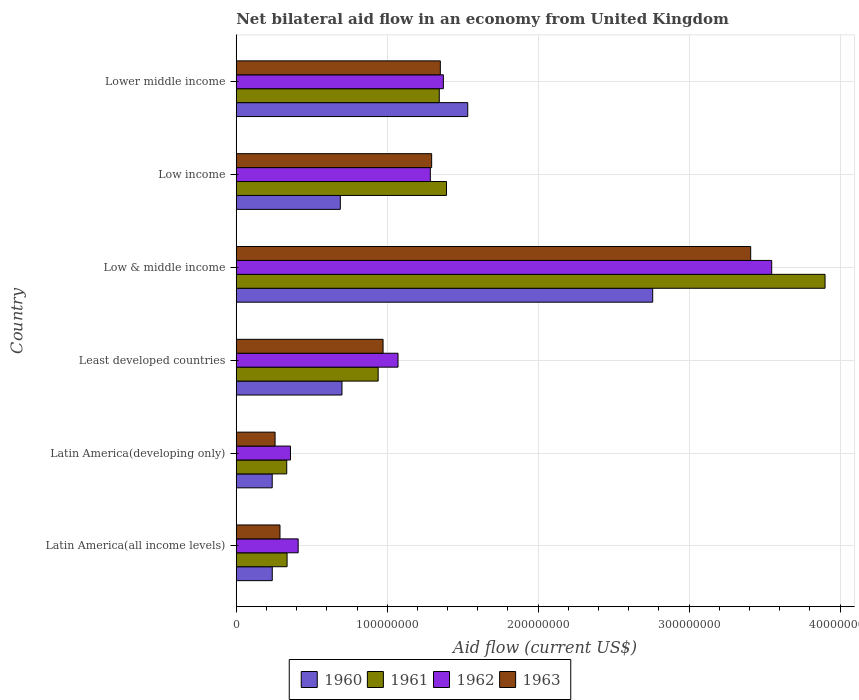How many different coloured bars are there?
Ensure brevity in your answer.  4. How many groups of bars are there?
Offer a terse response. 6. Are the number of bars per tick equal to the number of legend labels?
Offer a very short reply. Yes. What is the label of the 4th group of bars from the top?
Ensure brevity in your answer.  Least developed countries. In how many cases, is the number of bars for a given country not equal to the number of legend labels?
Keep it short and to the point. 0. What is the net bilateral aid flow in 1962 in Latin America(developing only)?
Provide a succinct answer. 3.59e+07. Across all countries, what is the maximum net bilateral aid flow in 1962?
Your answer should be very brief. 3.55e+08. Across all countries, what is the minimum net bilateral aid flow in 1962?
Ensure brevity in your answer.  3.59e+07. In which country was the net bilateral aid flow in 1961 minimum?
Make the answer very short. Latin America(developing only). What is the total net bilateral aid flow in 1962 in the graph?
Offer a very short reply. 8.05e+08. What is the difference between the net bilateral aid flow in 1962 in Low income and that in Lower middle income?
Give a very brief answer. -8.62e+06. What is the difference between the net bilateral aid flow in 1960 in Latin America(developing only) and the net bilateral aid flow in 1962 in Lower middle income?
Offer a very short reply. -1.13e+08. What is the average net bilateral aid flow in 1961 per country?
Keep it short and to the point. 1.38e+08. What is the difference between the net bilateral aid flow in 1961 and net bilateral aid flow in 1962 in Low & middle income?
Keep it short and to the point. 3.54e+07. What is the ratio of the net bilateral aid flow in 1960 in Latin America(all income levels) to that in Least developed countries?
Offer a terse response. 0.34. What is the difference between the highest and the second highest net bilateral aid flow in 1961?
Your answer should be very brief. 2.51e+08. What is the difference between the highest and the lowest net bilateral aid flow in 1960?
Offer a very short reply. 2.52e+08. Is it the case that in every country, the sum of the net bilateral aid flow in 1960 and net bilateral aid flow in 1962 is greater than the sum of net bilateral aid flow in 1963 and net bilateral aid flow in 1961?
Offer a terse response. No. Is it the case that in every country, the sum of the net bilateral aid flow in 1962 and net bilateral aid flow in 1960 is greater than the net bilateral aid flow in 1961?
Keep it short and to the point. Yes. What is the difference between two consecutive major ticks on the X-axis?
Ensure brevity in your answer.  1.00e+08. Are the values on the major ticks of X-axis written in scientific E-notation?
Your answer should be compact. No. Does the graph contain any zero values?
Make the answer very short. No. Where does the legend appear in the graph?
Your response must be concise. Bottom center. What is the title of the graph?
Your answer should be compact. Net bilateral aid flow in an economy from United Kingdom. Does "2001" appear as one of the legend labels in the graph?
Your answer should be very brief. No. What is the label or title of the Y-axis?
Provide a succinct answer. Country. What is the Aid flow (current US$) of 1960 in Latin America(all income levels)?
Give a very brief answer. 2.39e+07. What is the Aid flow (current US$) in 1961 in Latin America(all income levels)?
Offer a very short reply. 3.37e+07. What is the Aid flow (current US$) in 1962 in Latin America(all income levels)?
Keep it short and to the point. 4.10e+07. What is the Aid flow (current US$) in 1963 in Latin America(all income levels)?
Your answer should be compact. 2.90e+07. What is the Aid flow (current US$) of 1960 in Latin America(developing only)?
Your answer should be compact. 2.38e+07. What is the Aid flow (current US$) of 1961 in Latin America(developing only)?
Your answer should be compact. 3.34e+07. What is the Aid flow (current US$) of 1962 in Latin America(developing only)?
Your response must be concise. 3.59e+07. What is the Aid flow (current US$) in 1963 in Latin America(developing only)?
Ensure brevity in your answer.  2.57e+07. What is the Aid flow (current US$) in 1960 in Least developed countries?
Your answer should be compact. 7.00e+07. What is the Aid flow (current US$) in 1961 in Least developed countries?
Provide a succinct answer. 9.40e+07. What is the Aid flow (current US$) of 1962 in Least developed countries?
Your answer should be compact. 1.07e+08. What is the Aid flow (current US$) in 1963 in Least developed countries?
Provide a succinct answer. 9.73e+07. What is the Aid flow (current US$) in 1960 in Low & middle income?
Provide a succinct answer. 2.76e+08. What is the Aid flow (current US$) in 1961 in Low & middle income?
Your answer should be very brief. 3.90e+08. What is the Aid flow (current US$) in 1962 in Low & middle income?
Ensure brevity in your answer.  3.55e+08. What is the Aid flow (current US$) in 1963 in Low & middle income?
Ensure brevity in your answer.  3.41e+08. What is the Aid flow (current US$) of 1960 in Low income?
Provide a succinct answer. 6.90e+07. What is the Aid flow (current US$) of 1961 in Low income?
Keep it short and to the point. 1.39e+08. What is the Aid flow (current US$) of 1962 in Low income?
Your answer should be very brief. 1.29e+08. What is the Aid flow (current US$) in 1963 in Low income?
Ensure brevity in your answer.  1.29e+08. What is the Aid flow (current US$) of 1960 in Lower middle income?
Your answer should be very brief. 1.53e+08. What is the Aid flow (current US$) in 1961 in Lower middle income?
Make the answer very short. 1.34e+08. What is the Aid flow (current US$) of 1962 in Lower middle income?
Ensure brevity in your answer.  1.37e+08. What is the Aid flow (current US$) of 1963 in Lower middle income?
Your response must be concise. 1.35e+08. Across all countries, what is the maximum Aid flow (current US$) in 1960?
Provide a succinct answer. 2.76e+08. Across all countries, what is the maximum Aid flow (current US$) in 1961?
Your answer should be compact. 3.90e+08. Across all countries, what is the maximum Aid flow (current US$) in 1962?
Make the answer very short. 3.55e+08. Across all countries, what is the maximum Aid flow (current US$) in 1963?
Keep it short and to the point. 3.41e+08. Across all countries, what is the minimum Aid flow (current US$) of 1960?
Ensure brevity in your answer.  2.38e+07. Across all countries, what is the minimum Aid flow (current US$) of 1961?
Ensure brevity in your answer.  3.34e+07. Across all countries, what is the minimum Aid flow (current US$) in 1962?
Offer a very short reply. 3.59e+07. Across all countries, what is the minimum Aid flow (current US$) of 1963?
Provide a succinct answer. 2.57e+07. What is the total Aid flow (current US$) of 1960 in the graph?
Provide a succinct answer. 6.16e+08. What is the total Aid flow (current US$) of 1961 in the graph?
Provide a short and direct response. 8.25e+08. What is the total Aid flow (current US$) in 1962 in the graph?
Offer a terse response. 8.05e+08. What is the total Aid flow (current US$) of 1963 in the graph?
Keep it short and to the point. 7.57e+08. What is the difference between the Aid flow (current US$) in 1961 in Latin America(all income levels) and that in Latin America(developing only)?
Your response must be concise. 2.20e+05. What is the difference between the Aid flow (current US$) of 1962 in Latin America(all income levels) and that in Latin America(developing only)?
Offer a very short reply. 5.10e+06. What is the difference between the Aid flow (current US$) of 1963 in Latin America(all income levels) and that in Latin America(developing only)?
Your response must be concise. 3.25e+06. What is the difference between the Aid flow (current US$) of 1960 in Latin America(all income levels) and that in Least developed countries?
Your answer should be very brief. -4.62e+07. What is the difference between the Aid flow (current US$) in 1961 in Latin America(all income levels) and that in Least developed countries?
Provide a short and direct response. -6.04e+07. What is the difference between the Aid flow (current US$) of 1962 in Latin America(all income levels) and that in Least developed countries?
Your response must be concise. -6.62e+07. What is the difference between the Aid flow (current US$) in 1963 in Latin America(all income levels) and that in Least developed countries?
Your answer should be compact. -6.83e+07. What is the difference between the Aid flow (current US$) of 1960 in Latin America(all income levels) and that in Low & middle income?
Give a very brief answer. -2.52e+08. What is the difference between the Aid flow (current US$) in 1961 in Latin America(all income levels) and that in Low & middle income?
Your answer should be very brief. -3.56e+08. What is the difference between the Aid flow (current US$) of 1962 in Latin America(all income levels) and that in Low & middle income?
Keep it short and to the point. -3.14e+08. What is the difference between the Aid flow (current US$) of 1963 in Latin America(all income levels) and that in Low & middle income?
Offer a terse response. -3.12e+08. What is the difference between the Aid flow (current US$) of 1960 in Latin America(all income levels) and that in Low income?
Offer a very short reply. -4.51e+07. What is the difference between the Aid flow (current US$) of 1961 in Latin America(all income levels) and that in Low income?
Your response must be concise. -1.06e+08. What is the difference between the Aid flow (current US$) of 1962 in Latin America(all income levels) and that in Low income?
Provide a succinct answer. -8.76e+07. What is the difference between the Aid flow (current US$) in 1963 in Latin America(all income levels) and that in Low income?
Ensure brevity in your answer.  -1.00e+08. What is the difference between the Aid flow (current US$) in 1960 in Latin America(all income levels) and that in Lower middle income?
Ensure brevity in your answer.  -1.30e+08. What is the difference between the Aid flow (current US$) of 1961 in Latin America(all income levels) and that in Lower middle income?
Ensure brevity in your answer.  -1.01e+08. What is the difference between the Aid flow (current US$) of 1962 in Latin America(all income levels) and that in Lower middle income?
Your response must be concise. -9.62e+07. What is the difference between the Aid flow (current US$) of 1963 in Latin America(all income levels) and that in Lower middle income?
Your answer should be very brief. -1.06e+08. What is the difference between the Aid flow (current US$) in 1960 in Latin America(developing only) and that in Least developed countries?
Ensure brevity in your answer.  -4.62e+07. What is the difference between the Aid flow (current US$) in 1961 in Latin America(developing only) and that in Least developed countries?
Offer a terse response. -6.06e+07. What is the difference between the Aid flow (current US$) in 1962 in Latin America(developing only) and that in Least developed countries?
Ensure brevity in your answer.  -7.13e+07. What is the difference between the Aid flow (current US$) in 1963 in Latin America(developing only) and that in Least developed countries?
Ensure brevity in your answer.  -7.16e+07. What is the difference between the Aid flow (current US$) of 1960 in Latin America(developing only) and that in Low & middle income?
Ensure brevity in your answer.  -2.52e+08. What is the difference between the Aid flow (current US$) of 1961 in Latin America(developing only) and that in Low & middle income?
Make the answer very short. -3.57e+08. What is the difference between the Aid flow (current US$) of 1962 in Latin America(developing only) and that in Low & middle income?
Give a very brief answer. -3.19e+08. What is the difference between the Aid flow (current US$) in 1963 in Latin America(developing only) and that in Low & middle income?
Make the answer very short. -3.15e+08. What is the difference between the Aid flow (current US$) in 1960 in Latin America(developing only) and that in Low income?
Keep it short and to the point. -4.51e+07. What is the difference between the Aid flow (current US$) in 1961 in Latin America(developing only) and that in Low income?
Offer a terse response. -1.06e+08. What is the difference between the Aid flow (current US$) in 1962 in Latin America(developing only) and that in Low income?
Your answer should be compact. -9.27e+07. What is the difference between the Aid flow (current US$) of 1963 in Latin America(developing only) and that in Low income?
Offer a terse response. -1.04e+08. What is the difference between the Aid flow (current US$) in 1960 in Latin America(developing only) and that in Lower middle income?
Offer a very short reply. -1.30e+08. What is the difference between the Aid flow (current US$) in 1961 in Latin America(developing only) and that in Lower middle income?
Your answer should be very brief. -1.01e+08. What is the difference between the Aid flow (current US$) in 1962 in Latin America(developing only) and that in Lower middle income?
Offer a very short reply. -1.01e+08. What is the difference between the Aid flow (current US$) of 1963 in Latin America(developing only) and that in Lower middle income?
Offer a terse response. -1.09e+08. What is the difference between the Aid flow (current US$) of 1960 in Least developed countries and that in Low & middle income?
Offer a very short reply. -2.06e+08. What is the difference between the Aid flow (current US$) in 1961 in Least developed countries and that in Low & middle income?
Offer a terse response. -2.96e+08. What is the difference between the Aid flow (current US$) in 1962 in Least developed countries and that in Low & middle income?
Offer a very short reply. -2.48e+08. What is the difference between the Aid flow (current US$) of 1963 in Least developed countries and that in Low & middle income?
Your answer should be very brief. -2.44e+08. What is the difference between the Aid flow (current US$) of 1960 in Least developed countries and that in Low income?
Your answer should be very brief. 1.09e+06. What is the difference between the Aid flow (current US$) in 1961 in Least developed countries and that in Low income?
Give a very brief answer. -4.53e+07. What is the difference between the Aid flow (current US$) in 1962 in Least developed countries and that in Low income?
Ensure brevity in your answer.  -2.14e+07. What is the difference between the Aid flow (current US$) of 1963 in Least developed countries and that in Low income?
Keep it short and to the point. -3.22e+07. What is the difference between the Aid flow (current US$) of 1960 in Least developed countries and that in Lower middle income?
Give a very brief answer. -8.33e+07. What is the difference between the Aid flow (current US$) of 1961 in Least developed countries and that in Lower middle income?
Make the answer very short. -4.05e+07. What is the difference between the Aid flow (current US$) of 1962 in Least developed countries and that in Lower middle income?
Offer a very short reply. -3.00e+07. What is the difference between the Aid flow (current US$) of 1963 in Least developed countries and that in Lower middle income?
Your response must be concise. -3.79e+07. What is the difference between the Aid flow (current US$) in 1960 in Low & middle income and that in Low income?
Provide a short and direct response. 2.07e+08. What is the difference between the Aid flow (current US$) of 1961 in Low & middle income and that in Low income?
Make the answer very short. 2.51e+08. What is the difference between the Aid flow (current US$) in 1962 in Low & middle income and that in Low income?
Offer a terse response. 2.26e+08. What is the difference between the Aid flow (current US$) in 1963 in Low & middle income and that in Low income?
Ensure brevity in your answer.  2.11e+08. What is the difference between the Aid flow (current US$) in 1960 in Low & middle income and that in Lower middle income?
Give a very brief answer. 1.23e+08. What is the difference between the Aid flow (current US$) in 1961 in Low & middle income and that in Lower middle income?
Offer a terse response. 2.56e+08. What is the difference between the Aid flow (current US$) of 1962 in Low & middle income and that in Lower middle income?
Your response must be concise. 2.18e+08. What is the difference between the Aid flow (current US$) in 1963 in Low & middle income and that in Lower middle income?
Your answer should be compact. 2.06e+08. What is the difference between the Aid flow (current US$) in 1960 in Low income and that in Lower middle income?
Make the answer very short. -8.44e+07. What is the difference between the Aid flow (current US$) in 1961 in Low income and that in Lower middle income?
Ensure brevity in your answer.  4.79e+06. What is the difference between the Aid flow (current US$) in 1962 in Low income and that in Lower middle income?
Ensure brevity in your answer.  -8.62e+06. What is the difference between the Aid flow (current US$) in 1963 in Low income and that in Lower middle income?
Your answer should be very brief. -5.75e+06. What is the difference between the Aid flow (current US$) in 1960 in Latin America(all income levels) and the Aid flow (current US$) in 1961 in Latin America(developing only)?
Ensure brevity in your answer.  -9.59e+06. What is the difference between the Aid flow (current US$) of 1960 in Latin America(all income levels) and the Aid flow (current US$) of 1962 in Latin America(developing only)?
Provide a short and direct response. -1.21e+07. What is the difference between the Aid flow (current US$) of 1960 in Latin America(all income levels) and the Aid flow (current US$) of 1963 in Latin America(developing only)?
Provide a succinct answer. -1.86e+06. What is the difference between the Aid flow (current US$) of 1961 in Latin America(all income levels) and the Aid flow (current US$) of 1962 in Latin America(developing only)?
Offer a very short reply. -2.25e+06. What is the difference between the Aid flow (current US$) in 1961 in Latin America(all income levels) and the Aid flow (current US$) in 1963 in Latin America(developing only)?
Your answer should be compact. 7.95e+06. What is the difference between the Aid flow (current US$) of 1962 in Latin America(all income levels) and the Aid flow (current US$) of 1963 in Latin America(developing only)?
Your answer should be compact. 1.53e+07. What is the difference between the Aid flow (current US$) in 1960 in Latin America(all income levels) and the Aid flow (current US$) in 1961 in Least developed countries?
Keep it short and to the point. -7.02e+07. What is the difference between the Aid flow (current US$) in 1960 in Latin America(all income levels) and the Aid flow (current US$) in 1962 in Least developed countries?
Your answer should be compact. -8.33e+07. What is the difference between the Aid flow (current US$) of 1960 in Latin America(all income levels) and the Aid flow (current US$) of 1963 in Least developed countries?
Ensure brevity in your answer.  -7.34e+07. What is the difference between the Aid flow (current US$) in 1961 in Latin America(all income levels) and the Aid flow (current US$) in 1962 in Least developed countries?
Your response must be concise. -7.35e+07. What is the difference between the Aid flow (current US$) in 1961 in Latin America(all income levels) and the Aid flow (current US$) in 1963 in Least developed countries?
Provide a succinct answer. -6.36e+07. What is the difference between the Aid flow (current US$) in 1962 in Latin America(all income levels) and the Aid flow (current US$) in 1963 in Least developed countries?
Your answer should be very brief. -5.62e+07. What is the difference between the Aid flow (current US$) of 1960 in Latin America(all income levels) and the Aid flow (current US$) of 1961 in Low & middle income?
Your response must be concise. -3.66e+08. What is the difference between the Aid flow (current US$) of 1960 in Latin America(all income levels) and the Aid flow (current US$) of 1962 in Low & middle income?
Your answer should be very brief. -3.31e+08. What is the difference between the Aid flow (current US$) of 1960 in Latin America(all income levels) and the Aid flow (current US$) of 1963 in Low & middle income?
Offer a very short reply. -3.17e+08. What is the difference between the Aid flow (current US$) of 1961 in Latin America(all income levels) and the Aid flow (current US$) of 1962 in Low & middle income?
Offer a very short reply. -3.21e+08. What is the difference between the Aid flow (current US$) of 1961 in Latin America(all income levels) and the Aid flow (current US$) of 1963 in Low & middle income?
Make the answer very short. -3.07e+08. What is the difference between the Aid flow (current US$) in 1962 in Latin America(all income levels) and the Aid flow (current US$) in 1963 in Low & middle income?
Provide a succinct answer. -3.00e+08. What is the difference between the Aid flow (current US$) in 1960 in Latin America(all income levels) and the Aid flow (current US$) in 1961 in Low income?
Your response must be concise. -1.15e+08. What is the difference between the Aid flow (current US$) of 1960 in Latin America(all income levels) and the Aid flow (current US$) of 1962 in Low income?
Offer a very short reply. -1.05e+08. What is the difference between the Aid flow (current US$) in 1960 in Latin America(all income levels) and the Aid flow (current US$) in 1963 in Low income?
Make the answer very short. -1.06e+08. What is the difference between the Aid flow (current US$) of 1961 in Latin America(all income levels) and the Aid flow (current US$) of 1962 in Low income?
Give a very brief answer. -9.49e+07. What is the difference between the Aid flow (current US$) of 1961 in Latin America(all income levels) and the Aid flow (current US$) of 1963 in Low income?
Make the answer very short. -9.58e+07. What is the difference between the Aid flow (current US$) in 1962 in Latin America(all income levels) and the Aid flow (current US$) in 1963 in Low income?
Provide a succinct answer. -8.84e+07. What is the difference between the Aid flow (current US$) of 1960 in Latin America(all income levels) and the Aid flow (current US$) of 1961 in Lower middle income?
Your answer should be compact. -1.11e+08. What is the difference between the Aid flow (current US$) in 1960 in Latin America(all income levels) and the Aid flow (current US$) in 1962 in Lower middle income?
Provide a short and direct response. -1.13e+08. What is the difference between the Aid flow (current US$) in 1960 in Latin America(all income levels) and the Aid flow (current US$) in 1963 in Lower middle income?
Provide a short and direct response. -1.11e+08. What is the difference between the Aid flow (current US$) of 1961 in Latin America(all income levels) and the Aid flow (current US$) of 1962 in Lower middle income?
Offer a very short reply. -1.04e+08. What is the difference between the Aid flow (current US$) in 1961 in Latin America(all income levels) and the Aid flow (current US$) in 1963 in Lower middle income?
Your answer should be compact. -1.02e+08. What is the difference between the Aid flow (current US$) of 1962 in Latin America(all income levels) and the Aid flow (current US$) of 1963 in Lower middle income?
Your answer should be very brief. -9.42e+07. What is the difference between the Aid flow (current US$) of 1960 in Latin America(developing only) and the Aid flow (current US$) of 1961 in Least developed countries?
Your answer should be very brief. -7.02e+07. What is the difference between the Aid flow (current US$) of 1960 in Latin America(developing only) and the Aid flow (current US$) of 1962 in Least developed countries?
Your answer should be compact. -8.34e+07. What is the difference between the Aid flow (current US$) in 1960 in Latin America(developing only) and the Aid flow (current US$) in 1963 in Least developed countries?
Ensure brevity in your answer.  -7.34e+07. What is the difference between the Aid flow (current US$) of 1961 in Latin America(developing only) and the Aid flow (current US$) of 1962 in Least developed countries?
Provide a succinct answer. -7.37e+07. What is the difference between the Aid flow (current US$) in 1961 in Latin America(developing only) and the Aid flow (current US$) in 1963 in Least developed countries?
Provide a short and direct response. -6.38e+07. What is the difference between the Aid flow (current US$) of 1962 in Latin America(developing only) and the Aid flow (current US$) of 1963 in Least developed countries?
Make the answer very short. -6.14e+07. What is the difference between the Aid flow (current US$) in 1960 in Latin America(developing only) and the Aid flow (current US$) in 1961 in Low & middle income?
Ensure brevity in your answer.  -3.66e+08. What is the difference between the Aid flow (current US$) in 1960 in Latin America(developing only) and the Aid flow (current US$) in 1962 in Low & middle income?
Ensure brevity in your answer.  -3.31e+08. What is the difference between the Aid flow (current US$) in 1960 in Latin America(developing only) and the Aid flow (current US$) in 1963 in Low & middle income?
Ensure brevity in your answer.  -3.17e+08. What is the difference between the Aid flow (current US$) of 1961 in Latin America(developing only) and the Aid flow (current US$) of 1962 in Low & middle income?
Offer a very short reply. -3.21e+08. What is the difference between the Aid flow (current US$) in 1961 in Latin America(developing only) and the Aid flow (current US$) in 1963 in Low & middle income?
Offer a terse response. -3.07e+08. What is the difference between the Aid flow (current US$) in 1962 in Latin America(developing only) and the Aid flow (current US$) in 1963 in Low & middle income?
Give a very brief answer. -3.05e+08. What is the difference between the Aid flow (current US$) in 1960 in Latin America(developing only) and the Aid flow (current US$) in 1961 in Low income?
Provide a succinct answer. -1.15e+08. What is the difference between the Aid flow (current US$) of 1960 in Latin America(developing only) and the Aid flow (current US$) of 1962 in Low income?
Your answer should be very brief. -1.05e+08. What is the difference between the Aid flow (current US$) in 1960 in Latin America(developing only) and the Aid flow (current US$) in 1963 in Low income?
Your response must be concise. -1.06e+08. What is the difference between the Aid flow (current US$) in 1961 in Latin America(developing only) and the Aid flow (current US$) in 1962 in Low income?
Give a very brief answer. -9.51e+07. What is the difference between the Aid flow (current US$) of 1961 in Latin America(developing only) and the Aid flow (current US$) of 1963 in Low income?
Give a very brief answer. -9.60e+07. What is the difference between the Aid flow (current US$) in 1962 in Latin America(developing only) and the Aid flow (current US$) in 1963 in Low income?
Make the answer very short. -9.35e+07. What is the difference between the Aid flow (current US$) in 1960 in Latin America(developing only) and the Aid flow (current US$) in 1961 in Lower middle income?
Ensure brevity in your answer.  -1.11e+08. What is the difference between the Aid flow (current US$) in 1960 in Latin America(developing only) and the Aid flow (current US$) in 1962 in Lower middle income?
Provide a short and direct response. -1.13e+08. What is the difference between the Aid flow (current US$) of 1960 in Latin America(developing only) and the Aid flow (current US$) of 1963 in Lower middle income?
Keep it short and to the point. -1.11e+08. What is the difference between the Aid flow (current US$) in 1961 in Latin America(developing only) and the Aid flow (current US$) in 1962 in Lower middle income?
Offer a terse response. -1.04e+08. What is the difference between the Aid flow (current US$) in 1961 in Latin America(developing only) and the Aid flow (current US$) in 1963 in Lower middle income?
Make the answer very short. -1.02e+08. What is the difference between the Aid flow (current US$) of 1962 in Latin America(developing only) and the Aid flow (current US$) of 1963 in Lower middle income?
Provide a succinct answer. -9.93e+07. What is the difference between the Aid flow (current US$) in 1960 in Least developed countries and the Aid flow (current US$) in 1961 in Low & middle income?
Provide a short and direct response. -3.20e+08. What is the difference between the Aid flow (current US$) in 1960 in Least developed countries and the Aid flow (current US$) in 1962 in Low & middle income?
Provide a succinct answer. -2.85e+08. What is the difference between the Aid flow (current US$) in 1960 in Least developed countries and the Aid flow (current US$) in 1963 in Low & middle income?
Offer a terse response. -2.71e+08. What is the difference between the Aid flow (current US$) of 1961 in Least developed countries and the Aid flow (current US$) of 1962 in Low & middle income?
Your answer should be very brief. -2.61e+08. What is the difference between the Aid flow (current US$) of 1961 in Least developed countries and the Aid flow (current US$) of 1963 in Low & middle income?
Offer a terse response. -2.47e+08. What is the difference between the Aid flow (current US$) of 1962 in Least developed countries and the Aid flow (current US$) of 1963 in Low & middle income?
Ensure brevity in your answer.  -2.34e+08. What is the difference between the Aid flow (current US$) in 1960 in Least developed countries and the Aid flow (current US$) in 1961 in Low income?
Offer a terse response. -6.92e+07. What is the difference between the Aid flow (current US$) in 1960 in Least developed countries and the Aid flow (current US$) in 1962 in Low income?
Offer a terse response. -5.85e+07. What is the difference between the Aid flow (current US$) of 1960 in Least developed countries and the Aid flow (current US$) of 1963 in Low income?
Your answer should be compact. -5.94e+07. What is the difference between the Aid flow (current US$) of 1961 in Least developed countries and the Aid flow (current US$) of 1962 in Low income?
Offer a terse response. -3.46e+07. What is the difference between the Aid flow (current US$) of 1961 in Least developed countries and the Aid flow (current US$) of 1963 in Low income?
Offer a terse response. -3.54e+07. What is the difference between the Aid flow (current US$) of 1962 in Least developed countries and the Aid flow (current US$) of 1963 in Low income?
Provide a short and direct response. -2.23e+07. What is the difference between the Aid flow (current US$) of 1960 in Least developed countries and the Aid flow (current US$) of 1961 in Lower middle income?
Offer a very short reply. -6.45e+07. What is the difference between the Aid flow (current US$) in 1960 in Least developed countries and the Aid flow (current US$) in 1962 in Lower middle income?
Ensure brevity in your answer.  -6.72e+07. What is the difference between the Aid flow (current US$) of 1960 in Least developed countries and the Aid flow (current US$) of 1963 in Lower middle income?
Your response must be concise. -6.52e+07. What is the difference between the Aid flow (current US$) in 1961 in Least developed countries and the Aid flow (current US$) in 1962 in Lower middle income?
Give a very brief answer. -4.32e+07. What is the difference between the Aid flow (current US$) of 1961 in Least developed countries and the Aid flow (current US$) of 1963 in Lower middle income?
Keep it short and to the point. -4.12e+07. What is the difference between the Aid flow (current US$) in 1962 in Least developed countries and the Aid flow (current US$) in 1963 in Lower middle income?
Your response must be concise. -2.80e+07. What is the difference between the Aid flow (current US$) of 1960 in Low & middle income and the Aid flow (current US$) of 1961 in Low income?
Provide a succinct answer. 1.37e+08. What is the difference between the Aid flow (current US$) in 1960 in Low & middle income and the Aid flow (current US$) in 1962 in Low income?
Your answer should be compact. 1.47e+08. What is the difference between the Aid flow (current US$) in 1960 in Low & middle income and the Aid flow (current US$) in 1963 in Low income?
Your response must be concise. 1.46e+08. What is the difference between the Aid flow (current US$) in 1961 in Low & middle income and the Aid flow (current US$) in 1962 in Low income?
Your response must be concise. 2.62e+08. What is the difference between the Aid flow (current US$) of 1961 in Low & middle income and the Aid flow (current US$) of 1963 in Low income?
Make the answer very short. 2.61e+08. What is the difference between the Aid flow (current US$) of 1962 in Low & middle income and the Aid flow (current US$) of 1963 in Low income?
Provide a short and direct response. 2.25e+08. What is the difference between the Aid flow (current US$) of 1960 in Low & middle income and the Aid flow (current US$) of 1961 in Lower middle income?
Keep it short and to the point. 1.41e+08. What is the difference between the Aid flow (current US$) in 1960 in Low & middle income and the Aid flow (current US$) in 1962 in Lower middle income?
Provide a succinct answer. 1.39e+08. What is the difference between the Aid flow (current US$) of 1960 in Low & middle income and the Aid flow (current US$) of 1963 in Lower middle income?
Keep it short and to the point. 1.41e+08. What is the difference between the Aid flow (current US$) in 1961 in Low & middle income and the Aid flow (current US$) in 1962 in Lower middle income?
Your answer should be compact. 2.53e+08. What is the difference between the Aid flow (current US$) of 1961 in Low & middle income and the Aid flow (current US$) of 1963 in Lower middle income?
Offer a terse response. 2.55e+08. What is the difference between the Aid flow (current US$) in 1962 in Low & middle income and the Aid flow (current US$) in 1963 in Lower middle income?
Give a very brief answer. 2.20e+08. What is the difference between the Aid flow (current US$) in 1960 in Low income and the Aid flow (current US$) in 1961 in Lower middle income?
Ensure brevity in your answer.  -6.56e+07. What is the difference between the Aid flow (current US$) in 1960 in Low income and the Aid flow (current US$) in 1962 in Lower middle income?
Your response must be concise. -6.82e+07. What is the difference between the Aid flow (current US$) of 1960 in Low income and the Aid flow (current US$) of 1963 in Lower middle income?
Your answer should be very brief. -6.63e+07. What is the difference between the Aid flow (current US$) in 1961 in Low income and the Aid flow (current US$) in 1962 in Lower middle income?
Keep it short and to the point. 2.09e+06. What is the difference between the Aid flow (current US$) in 1961 in Low income and the Aid flow (current US$) in 1963 in Lower middle income?
Offer a terse response. 4.08e+06. What is the difference between the Aid flow (current US$) of 1962 in Low income and the Aid flow (current US$) of 1963 in Lower middle income?
Provide a short and direct response. -6.63e+06. What is the average Aid flow (current US$) of 1960 per country?
Give a very brief answer. 1.03e+08. What is the average Aid flow (current US$) in 1961 per country?
Ensure brevity in your answer.  1.38e+08. What is the average Aid flow (current US$) of 1962 per country?
Your response must be concise. 1.34e+08. What is the average Aid flow (current US$) in 1963 per country?
Provide a short and direct response. 1.26e+08. What is the difference between the Aid flow (current US$) of 1960 and Aid flow (current US$) of 1961 in Latin America(all income levels)?
Keep it short and to the point. -9.81e+06. What is the difference between the Aid flow (current US$) in 1960 and Aid flow (current US$) in 1962 in Latin America(all income levels)?
Provide a succinct answer. -1.72e+07. What is the difference between the Aid flow (current US$) of 1960 and Aid flow (current US$) of 1963 in Latin America(all income levels)?
Offer a very short reply. -5.11e+06. What is the difference between the Aid flow (current US$) in 1961 and Aid flow (current US$) in 1962 in Latin America(all income levels)?
Offer a very short reply. -7.35e+06. What is the difference between the Aid flow (current US$) in 1961 and Aid flow (current US$) in 1963 in Latin America(all income levels)?
Your answer should be very brief. 4.70e+06. What is the difference between the Aid flow (current US$) of 1962 and Aid flow (current US$) of 1963 in Latin America(all income levels)?
Provide a succinct answer. 1.20e+07. What is the difference between the Aid flow (current US$) of 1960 and Aid flow (current US$) of 1961 in Latin America(developing only)?
Ensure brevity in your answer.  -9.62e+06. What is the difference between the Aid flow (current US$) of 1960 and Aid flow (current US$) of 1962 in Latin America(developing only)?
Keep it short and to the point. -1.21e+07. What is the difference between the Aid flow (current US$) of 1960 and Aid flow (current US$) of 1963 in Latin America(developing only)?
Make the answer very short. -1.89e+06. What is the difference between the Aid flow (current US$) in 1961 and Aid flow (current US$) in 1962 in Latin America(developing only)?
Ensure brevity in your answer.  -2.47e+06. What is the difference between the Aid flow (current US$) in 1961 and Aid flow (current US$) in 1963 in Latin America(developing only)?
Provide a succinct answer. 7.73e+06. What is the difference between the Aid flow (current US$) in 1962 and Aid flow (current US$) in 1963 in Latin America(developing only)?
Offer a terse response. 1.02e+07. What is the difference between the Aid flow (current US$) in 1960 and Aid flow (current US$) in 1961 in Least developed countries?
Provide a succinct answer. -2.40e+07. What is the difference between the Aid flow (current US$) in 1960 and Aid flow (current US$) in 1962 in Least developed countries?
Keep it short and to the point. -3.71e+07. What is the difference between the Aid flow (current US$) in 1960 and Aid flow (current US$) in 1963 in Least developed countries?
Offer a very short reply. -2.72e+07. What is the difference between the Aid flow (current US$) of 1961 and Aid flow (current US$) of 1962 in Least developed countries?
Your answer should be compact. -1.32e+07. What is the difference between the Aid flow (current US$) of 1961 and Aid flow (current US$) of 1963 in Least developed countries?
Offer a terse response. -3.25e+06. What is the difference between the Aid flow (current US$) of 1962 and Aid flow (current US$) of 1963 in Least developed countries?
Your answer should be compact. 9.91e+06. What is the difference between the Aid flow (current US$) in 1960 and Aid flow (current US$) in 1961 in Low & middle income?
Your answer should be very brief. -1.14e+08. What is the difference between the Aid flow (current US$) of 1960 and Aid flow (current US$) of 1962 in Low & middle income?
Offer a terse response. -7.88e+07. What is the difference between the Aid flow (current US$) of 1960 and Aid flow (current US$) of 1963 in Low & middle income?
Make the answer very short. -6.49e+07. What is the difference between the Aid flow (current US$) of 1961 and Aid flow (current US$) of 1962 in Low & middle income?
Ensure brevity in your answer.  3.54e+07. What is the difference between the Aid flow (current US$) of 1961 and Aid flow (current US$) of 1963 in Low & middle income?
Your answer should be very brief. 4.93e+07. What is the difference between the Aid flow (current US$) in 1962 and Aid flow (current US$) in 1963 in Low & middle income?
Make the answer very short. 1.39e+07. What is the difference between the Aid flow (current US$) in 1960 and Aid flow (current US$) in 1961 in Low income?
Ensure brevity in your answer.  -7.03e+07. What is the difference between the Aid flow (current US$) in 1960 and Aid flow (current US$) in 1962 in Low income?
Give a very brief answer. -5.96e+07. What is the difference between the Aid flow (current US$) in 1960 and Aid flow (current US$) in 1963 in Low income?
Offer a very short reply. -6.05e+07. What is the difference between the Aid flow (current US$) of 1961 and Aid flow (current US$) of 1962 in Low income?
Offer a terse response. 1.07e+07. What is the difference between the Aid flow (current US$) of 1961 and Aid flow (current US$) of 1963 in Low income?
Your response must be concise. 9.83e+06. What is the difference between the Aid flow (current US$) in 1962 and Aid flow (current US$) in 1963 in Low income?
Your answer should be compact. -8.80e+05. What is the difference between the Aid flow (current US$) in 1960 and Aid flow (current US$) in 1961 in Lower middle income?
Provide a succinct answer. 1.89e+07. What is the difference between the Aid flow (current US$) in 1960 and Aid flow (current US$) in 1962 in Lower middle income?
Offer a terse response. 1.62e+07. What is the difference between the Aid flow (current US$) in 1960 and Aid flow (current US$) in 1963 in Lower middle income?
Provide a succinct answer. 1.82e+07. What is the difference between the Aid flow (current US$) of 1961 and Aid flow (current US$) of 1962 in Lower middle income?
Offer a very short reply. -2.70e+06. What is the difference between the Aid flow (current US$) in 1961 and Aid flow (current US$) in 1963 in Lower middle income?
Ensure brevity in your answer.  -7.10e+05. What is the difference between the Aid flow (current US$) of 1962 and Aid flow (current US$) of 1963 in Lower middle income?
Give a very brief answer. 1.99e+06. What is the ratio of the Aid flow (current US$) of 1960 in Latin America(all income levels) to that in Latin America(developing only)?
Give a very brief answer. 1. What is the ratio of the Aid flow (current US$) of 1961 in Latin America(all income levels) to that in Latin America(developing only)?
Offer a terse response. 1.01. What is the ratio of the Aid flow (current US$) of 1962 in Latin America(all income levels) to that in Latin America(developing only)?
Offer a terse response. 1.14. What is the ratio of the Aid flow (current US$) of 1963 in Latin America(all income levels) to that in Latin America(developing only)?
Keep it short and to the point. 1.13. What is the ratio of the Aid flow (current US$) of 1960 in Latin America(all income levels) to that in Least developed countries?
Ensure brevity in your answer.  0.34. What is the ratio of the Aid flow (current US$) in 1961 in Latin America(all income levels) to that in Least developed countries?
Provide a succinct answer. 0.36. What is the ratio of the Aid flow (current US$) of 1962 in Latin America(all income levels) to that in Least developed countries?
Provide a succinct answer. 0.38. What is the ratio of the Aid flow (current US$) of 1963 in Latin America(all income levels) to that in Least developed countries?
Give a very brief answer. 0.3. What is the ratio of the Aid flow (current US$) in 1960 in Latin America(all income levels) to that in Low & middle income?
Your answer should be very brief. 0.09. What is the ratio of the Aid flow (current US$) in 1961 in Latin America(all income levels) to that in Low & middle income?
Ensure brevity in your answer.  0.09. What is the ratio of the Aid flow (current US$) of 1962 in Latin America(all income levels) to that in Low & middle income?
Provide a succinct answer. 0.12. What is the ratio of the Aid flow (current US$) in 1963 in Latin America(all income levels) to that in Low & middle income?
Provide a short and direct response. 0.09. What is the ratio of the Aid flow (current US$) of 1960 in Latin America(all income levels) to that in Low income?
Give a very brief answer. 0.35. What is the ratio of the Aid flow (current US$) in 1961 in Latin America(all income levels) to that in Low income?
Your response must be concise. 0.24. What is the ratio of the Aid flow (current US$) in 1962 in Latin America(all income levels) to that in Low income?
Provide a succinct answer. 0.32. What is the ratio of the Aid flow (current US$) of 1963 in Latin America(all income levels) to that in Low income?
Give a very brief answer. 0.22. What is the ratio of the Aid flow (current US$) in 1960 in Latin America(all income levels) to that in Lower middle income?
Offer a very short reply. 0.16. What is the ratio of the Aid flow (current US$) in 1961 in Latin America(all income levels) to that in Lower middle income?
Ensure brevity in your answer.  0.25. What is the ratio of the Aid flow (current US$) of 1962 in Latin America(all income levels) to that in Lower middle income?
Your response must be concise. 0.3. What is the ratio of the Aid flow (current US$) of 1963 in Latin America(all income levels) to that in Lower middle income?
Offer a very short reply. 0.21. What is the ratio of the Aid flow (current US$) of 1960 in Latin America(developing only) to that in Least developed countries?
Your response must be concise. 0.34. What is the ratio of the Aid flow (current US$) of 1961 in Latin America(developing only) to that in Least developed countries?
Give a very brief answer. 0.36. What is the ratio of the Aid flow (current US$) of 1962 in Latin America(developing only) to that in Least developed countries?
Give a very brief answer. 0.34. What is the ratio of the Aid flow (current US$) of 1963 in Latin America(developing only) to that in Least developed countries?
Your response must be concise. 0.26. What is the ratio of the Aid flow (current US$) in 1960 in Latin America(developing only) to that in Low & middle income?
Give a very brief answer. 0.09. What is the ratio of the Aid flow (current US$) in 1961 in Latin America(developing only) to that in Low & middle income?
Provide a succinct answer. 0.09. What is the ratio of the Aid flow (current US$) of 1962 in Latin America(developing only) to that in Low & middle income?
Provide a succinct answer. 0.1. What is the ratio of the Aid flow (current US$) of 1963 in Latin America(developing only) to that in Low & middle income?
Make the answer very short. 0.08. What is the ratio of the Aid flow (current US$) in 1960 in Latin America(developing only) to that in Low income?
Offer a very short reply. 0.35. What is the ratio of the Aid flow (current US$) in 1961 in Latin America(developing only) to that in Low income?
Your answer should be compact. 0.24. What is the ratio of the Aid flow (current US$) in 1962 in Latin America(developing only) to that in Low income?
Ensure brevity in your answer.  0.28. What is the ratio of the Aid flow (current US$) in 1963 in Latin America(developing only) to that in Low income?
Offer a terse response. 0.2. What is the ratio of the Aid flow (current US$) in 1960 in Latin America(developing only) to that in Lower middle income?
Ensure brevity in your answer.  0.16. What is the ratio of the Aid flow (current US$) of 1961 in Latin America(developing only) to that in Lower middle income?
Provide a succinct answer. 0.25. What is the ratio of the Aid flow (current US$) of 1962 in Latin America(developing only) to that in Lower middle income?
Give a very brief answer. 0.26. What is the ratio of the Aid flow (current US$) of 1963 in Latin America(developing only) to that in Lower middle income?
Offer a terse response. 0.19. What is the ratio of the Aid flow (current US$) in 1960 in Least developed countries to that in Low & middle income?
Offer a terse response. 0.25. What is the ratio of the Aid flow (current US$) in 1961 in Least developed countries to that in Low & middle income?
Your answer should be compact. 0.24. What is the ratio of the Aid flow (current US$) of 1962 in Least developed countries to that in Low & middle income?
Make the answer very short. 0.3. What is the ratio of the Aid flow (current US$) of 1963 in Least developed countries to that in Low & middle income?
Offer a terse response. 0.29. What is the ratio of the Aid flow (current US$) of 1960 in Least developed countries to that in Low income?
Keep it short and to the point. 1.02. What is the ratio of the Aid flow (current US$) in 1961 in Least developed countries to that in Low income?
Keep it short and to the point. 0.68. What is the ratio of the Aid flow (current US$) of 1962 in Least developed countries to that in Low income?
Ensure brevity in your answer.  0.83. What is the ratio of the Aid flow (current US$) of 1963 in Least developed countries to that in Low income?
Give a very brief answer. 0.75. What is the ratio of the Aid flow (current US$) in 1960 in Least developed countries to that in Lower middle income?
Your answer should be compact. 0.46. What is the ratio of the Aid flow (current US$) of 1961 in Least developed countries to that in Lower middle income?
Provide a short and direct response. 0.7. What is the ratio of the Aid flow (current US$) in 1962 in Least developed countries to that in Lower middle income?
Keep it short and to the point. 0.78. What is the ratio of the Aid flow (current US$) in 1963 in Least developed countries to that in Lower middle income?
Your answer should be very brief. 0.72. What is the ratio of the Aid flow (current US$) of 1960 in Low & middle income to that in Low income?
Ensure brevity in your answer.  4. What is the ratio of the Aid flow (current US$) in 1961 in Low & middle income to that in Low income?
Ensure brevity in your answer.  2.8. What is the ratio of the Aid flow (current US$) in 1962 in Low & middle income to that in Low income?
Your answer should be very brief. 2.76. What is the ratio of the Aid flow (current US$) of 1963 in Low & middle income to that in Low income?
Give a very brief answer. 2.63. What is the ratio of the Aid flow (current US$) of 1960 in Low & middle income to that in Lower middle income?
Your answer should be compact. 1.8. What is the ratio of the Aid flow (current US$) in 1961 in Low & middle income to that in Lower middle income?
Ensure brevity in your answer.  2.9. What is the ratio of the Aid flow (current US$) in 1962 in Low & middle income to that in Lower middle income?
Provide a short and direct response. 2.59. What is the ratio of the Aid flow (current US$) of 1963 in Low & middle income to that in Lower middle income?
Provide a short and direct response. 2.52. What is the ratio of the Aid flow (current US$) of 1960 in Low income to that in Lower middle income?
Your answer should be compact. 0.45. What is the ratio of the Aid flow (current US$) of 1961 in Low income to that in Lower middle income?
Provide a short and direct response. 1.04. What is the ratio of the Aid flow (current US$) in 1962 in Low income to that in Lower middle income?
Provide a short and direct response. 0.94. What is the ratio of the Aid flow (current US$) in 1963 in Low income to that in Lower middle income?
Provide a succinct answer. 0.96. What is the difference between the highest and the second highest Aid flow (current US$) in 1960?
Provide a succinct answer. 1.23e+08. What is the difference between the highest and the second highest Aid flow (current US$) of 1961?
Ensure brevity in your answer.  2.51e+08. What is the difference between the highest and the second highest Aid flow (current US$) of 1962?
Provide a short and direct response. 2.18e+08. What is the difference between the highest and the second highest Aid flow (current US$) of 1963?
Provide a short and direct response. 2.06e+08. What is the difference between the highest and the lowest Aid flow (current US$) of 1960?
Offer a very short reply. 2.52e+08. What is the difference between the highest and the lowest Aid flow (current US$) in 1961?
Provide a short and direct response. 3.57e+08. What is the difference between the highest and the lowest Aid flow (current US$) of 1962?
Ensure brevity in your answer.  3.19e+08. What is the difference between the highest and the lowest Aid flow (current US$) in 1963?
Your answer should be compact. 3.15e+08. 